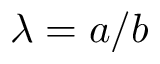Convert formula to latex. <formula><loc_0><loc_0><loc_500><loc_500>\lambda = a / b</formula> 